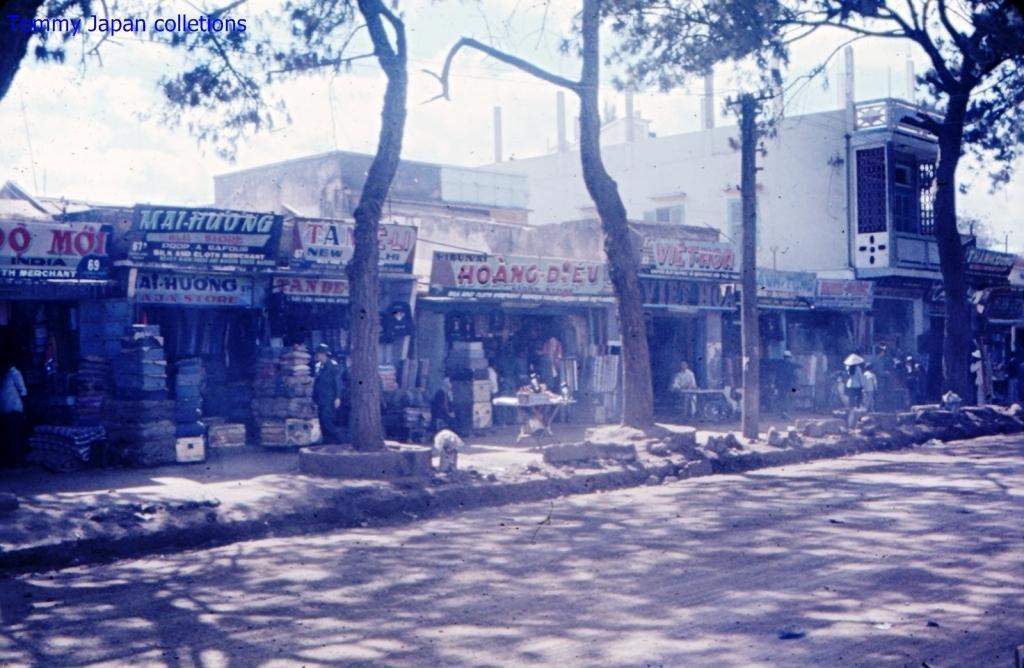Can you describe this image briefly? In this picture we can see the road, stones, trees, buildings, banners and some objects and in the background we can see the sky. 